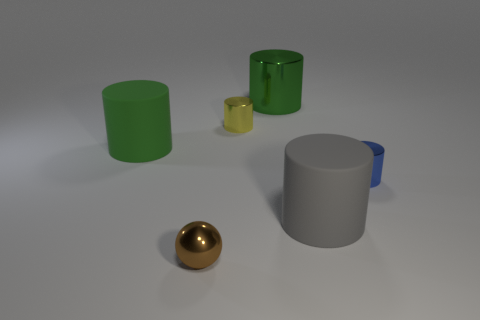Does the tiny sphere have the same material as the large cylinder that is right of the large green metal cylinder?
Your response must be concise. No. What number of gray things are shiny spheres or large rubber things?
Keep it short and to the point. 1. Are there any cylinders that have the same size as the green metal thing?
Offer a terse response. Yes. What is the material of the thing that is in front of the big matte thing that is on the right side of the small shiny cylinder that is behind the blue metal cylinder?
Your answer should be very brief. Metal. Are there the same number of shiny spheres that are behind the big shiny thing and tiny blue matte blocks?
Give a very brief answer. Yes. Are the small cylinder that is on the right side of the big green metal cylinder and the object in front of the gray matte cylinder made of the same material?
Offer a terse response. Yes. How many things are either spheres or tiny brown metal things in front of the big gray cylinder?
Your answer should be very brief. 1. Is there another yellow object that has the same shape as the big metal object?
Make the answer very short. Yes. There is a metallic cylinder that is in front of the large matte cylinder on the left side of the small metal object behind the tiny blue object; what is its size?
Offer a terse response. Small. Are there an equal number of green cylinders to the left of the big shiny thing and blue shiny cylinders that are behind the blue metallic thing?
Your answer should be very brief. No. 